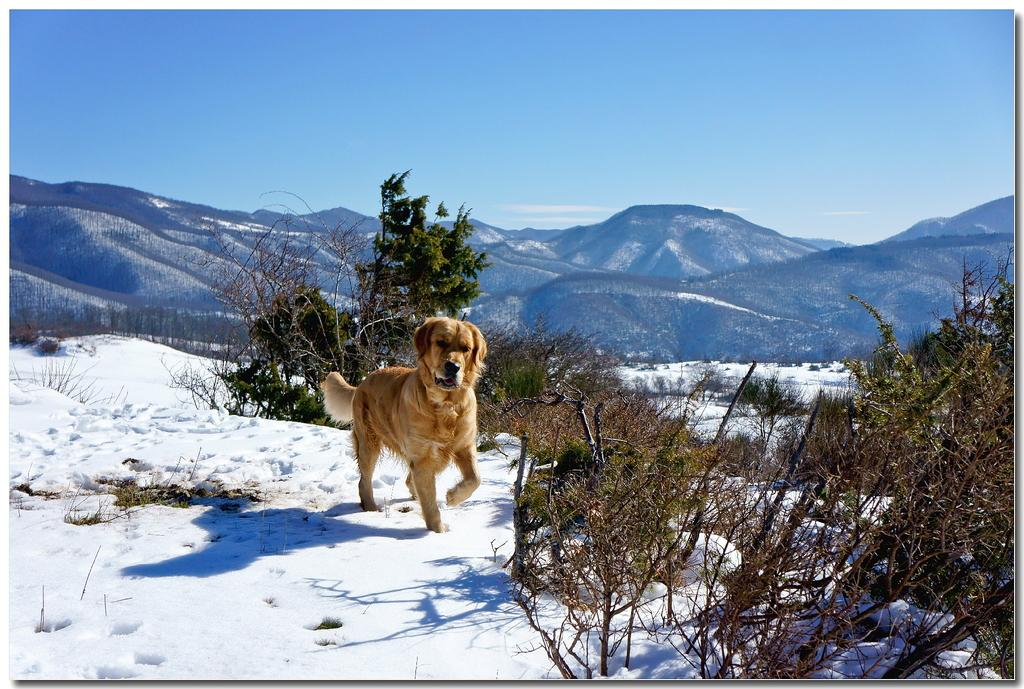What animal is present in the image? There is a dog in the image. What surface is the dog on? The dog is on an ice surface. What type of vegetation can be seen around the dog? There are trees around the dog. What can be seen in the distance behind the dog? There are mountains in the background of the image. What type of attraction is the dog visiting in the image? There is no indication of an attraction in the image; it simply shows a dog on an ice surface with trees and mountains in the background. 